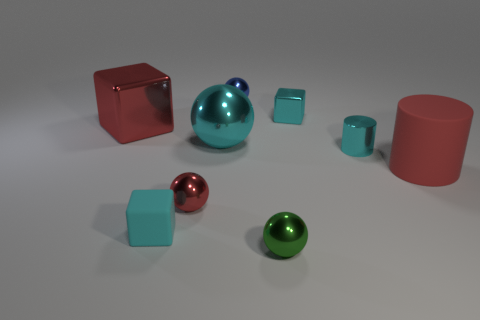There is a tiny shiny sphere in front of the tiny cyan object that is in front of the small metallic cylinder; is there a cyan metal cylinder to the right of it?
Make the answer very short. Yes. Does the small cyan thing that is behind the large red shiny block have the same shape as the small thing in front of the small cyan rubber thing?
Your answer should be compact. No. There is a big ball that is the same material as the green object; what is its color?
Your answer should be very brief. Cyan. Is the number of large cyan objects in front of the cyan metallic ball less than the number of large gray rubber cubes?
Provide a succinct answer. No. What size is the metallic block that is on the left side of the metallic block that is right of the metallic object to the left of the red metallic ball?
Your response must be concise. Large. Is the small cyan thing to the left of the green object made of the same material as the green sphere?
Offer a terse response. No. There is a small cylinder that is the same color as the small matte object; what is it made of?
Provide a succinct answer. Metal. How many objects are tiny red objects or big cyan metal things?
Your response must be concise. 2. The cyan thing that is the same shape as the small red thing is what size?
Offer a very short reply. Large. What number of other objects are the same color as the large cube?
Your answer should be compact. 2. 